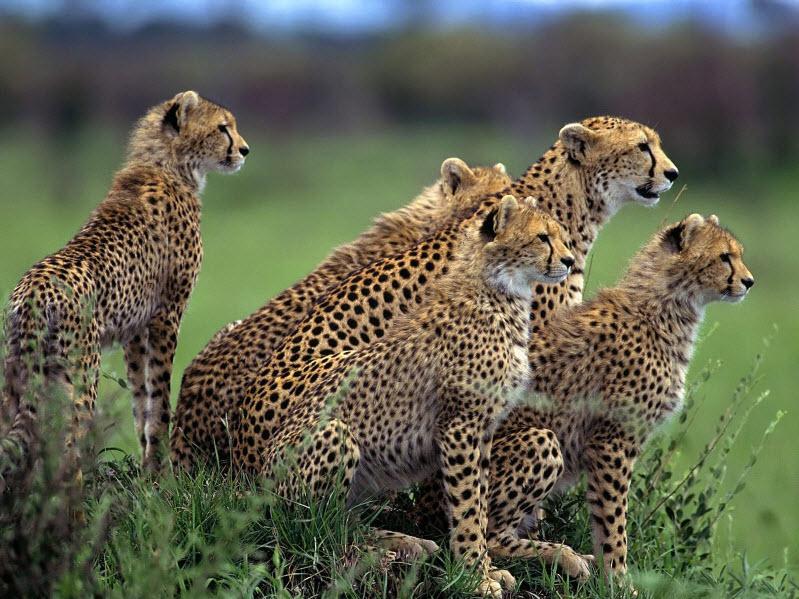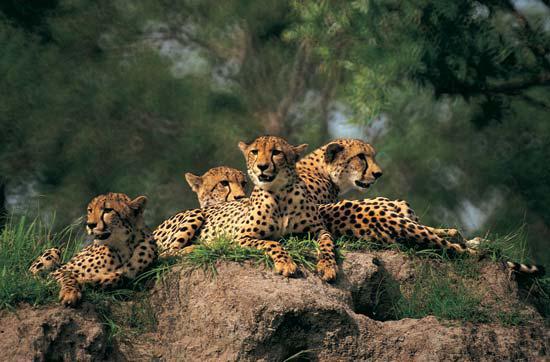The first image is the image on the left, the second image is the image on the right. Assess this claim about the two images: "The right image contains two or less baby cheetahs.". Correct or not? Answer yes or no. No. The first image is the image on the left, the second image is the image on the right. Analyze the images presented: Is the assertion "Left image shows a close group of at least four cheetahs." valid? Answer yes or no. Yes. 